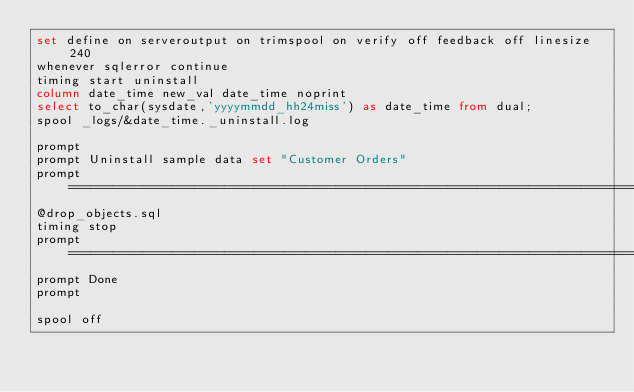<code> <loc_0><loc_0><loc_500><loc_500><_SQL_>set define on serveroutput on trimspool on verify off feedback off linesize 240
whenever sqlerror continue
timing start uninstall
column date_time new_val date_time noprint
select to_char(sysdate,'yyyymmdd_hh24miss') as date_time from dual;
spool _logs/&date_time._uninstall.log

prompt
prompt Uninstall sample data set "Customer Orders"
prompt ================================================================================
@drop_objects.sql
timing stop
prompt ================================================================================
prompt Done
prompt

spool off
</code> 